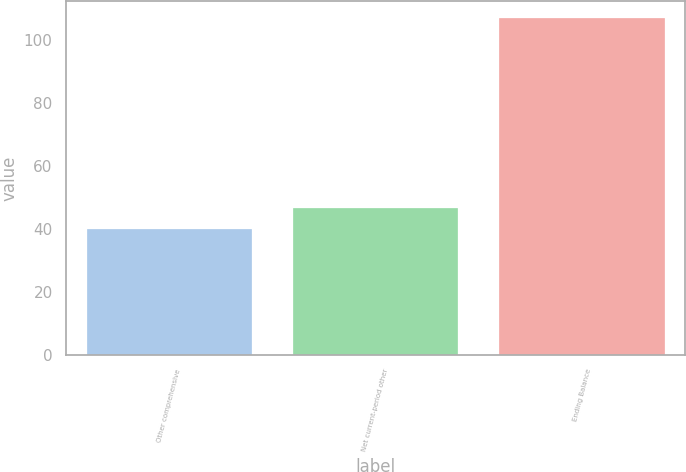<chart> <loc_0><loc_0><loc_500><loc_500><bar_chart><fcel>Other comprehensive<fcel>Net current-period other<fcel>Ending Balance<nl><fcel>40<fcel>46.7<fcel>107<nl></chart> 